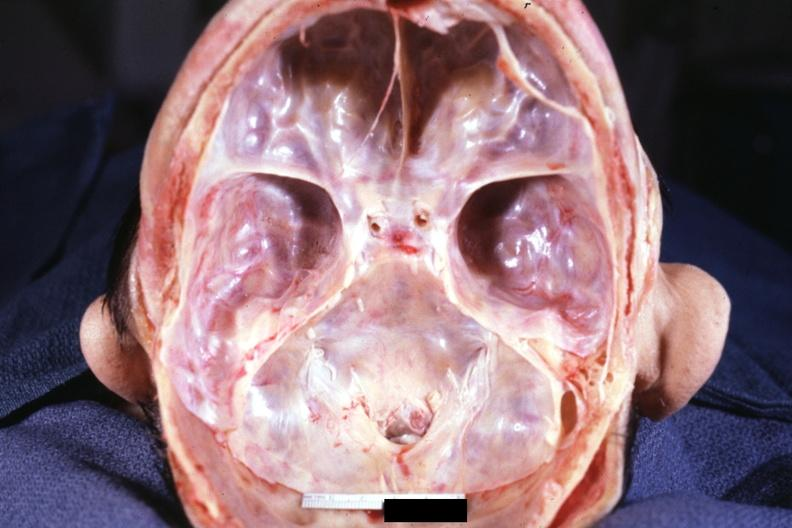s bone, calvarium present?
Answer the question using a single word or phrase. Yes 